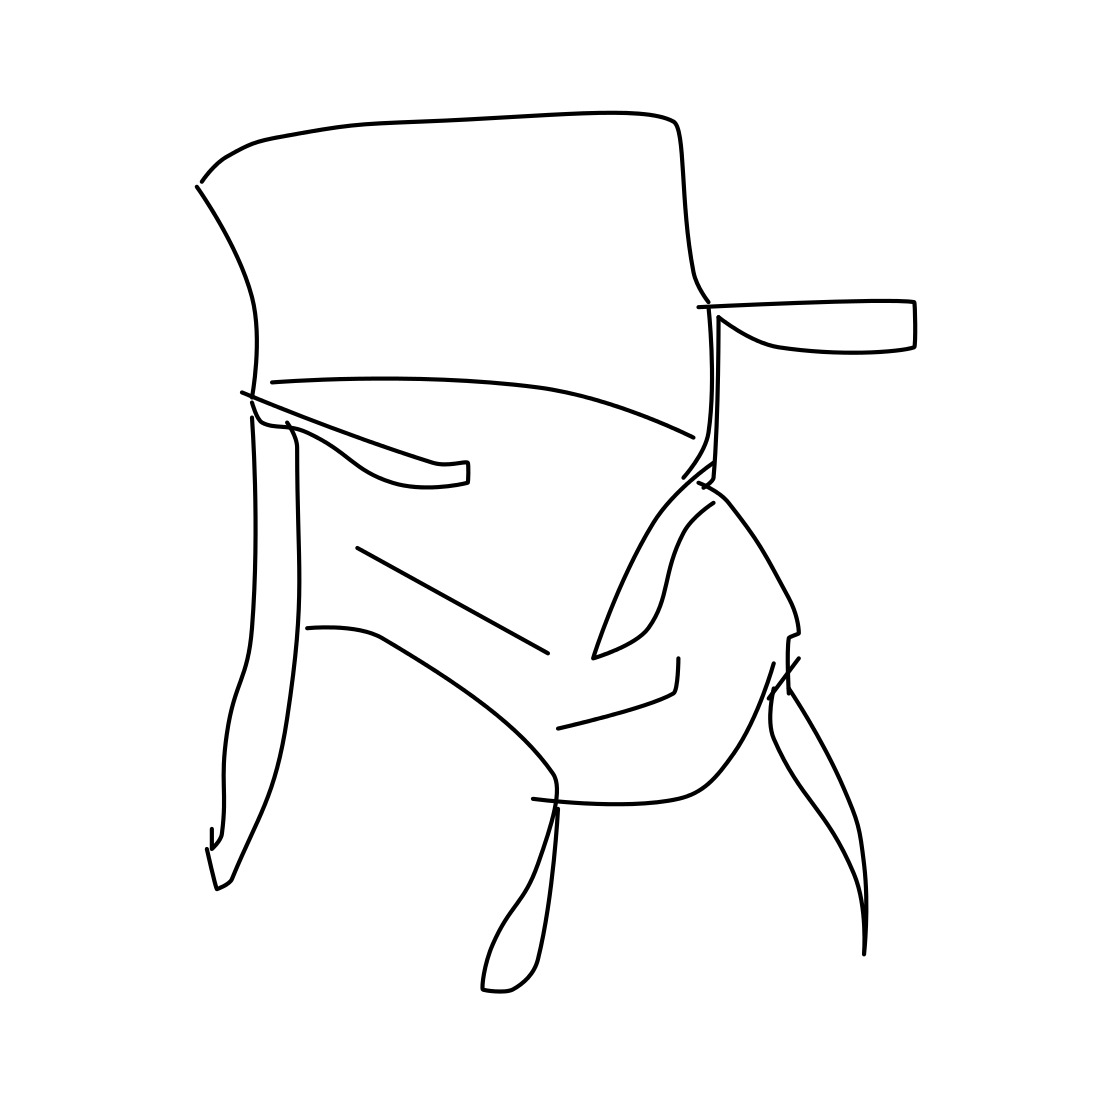Could this image be part of a larger collection? Yes, this image could be part of a series exploring abstraction and form with minimalist line drawings. Artists often create collections to explore a theme or concept in depth. 